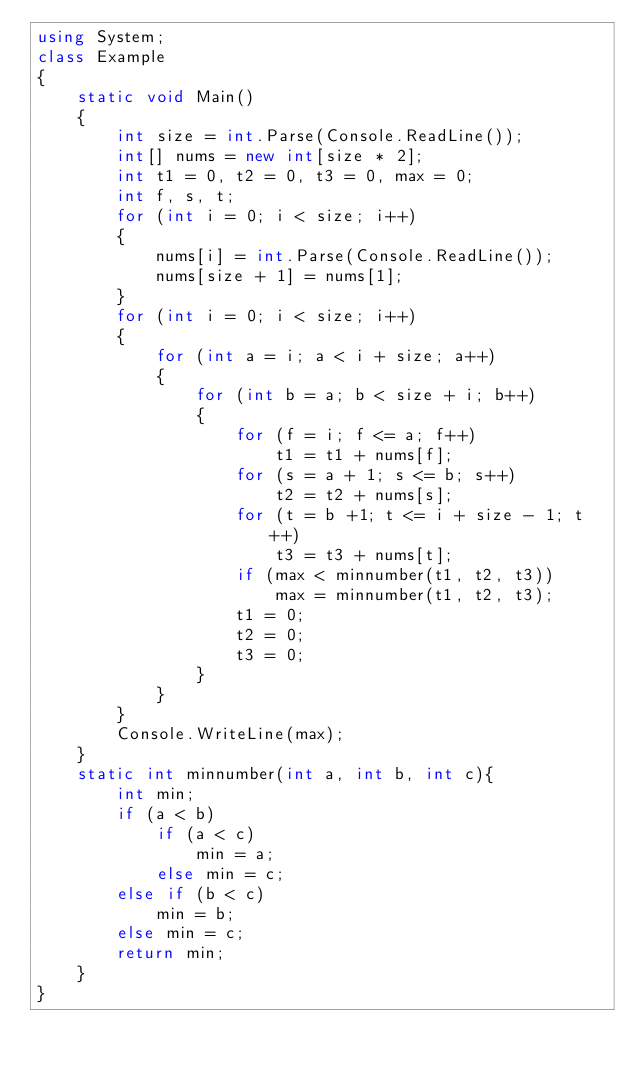<code> <loc_0><loc_0><loc_500><loc_500><_C#_>using System;
class Example
{
    static void Main()
    {
        int size = int.Parse(Console.ReadLine());
        int[] nums = new int[size * 2];
        int t1 = 0, t2 = 0, t3 = 0, max = 0;
        int f, s, t;
        for (int i = 0; i < size; i++)
        {
            nums[i] = int.Parse(Console.ReadLine());
            nums[size + 1] = nums[1];
        }
        for (int i = 0; i < size; i++)
        {
            for (int a = i; a < i + size; a++)
            {
                for (int b = a; b < size + i; b++)
                {
                    for (f = i; f <= a; f++)
                        t1 = t1 + nums[f];
                    for (s = a + 1; s <= b; s++)
                        t2 = t2 + nums[s];
                    for (t = b +1; t <= i + size - 1; t++)
                        t3 = t3 + nums[t];
                    if (max < minnumber(t1, t2, t3))
                        max = minnumber(t1, t2, t3);
                    t1 = 0;
                    t2 = 0;
                    t3 = 0;
                }
            }
        }
        Console.WriteLine(max);
    }
    static int minnumber(int a, int b, int c){
        int min;
        if (a < b)
            if (a < c)
                min = a;
            else min = c;
        else if (b < c)
            min = b;
        else min = c;
        return min;
    }
}
   </code> 